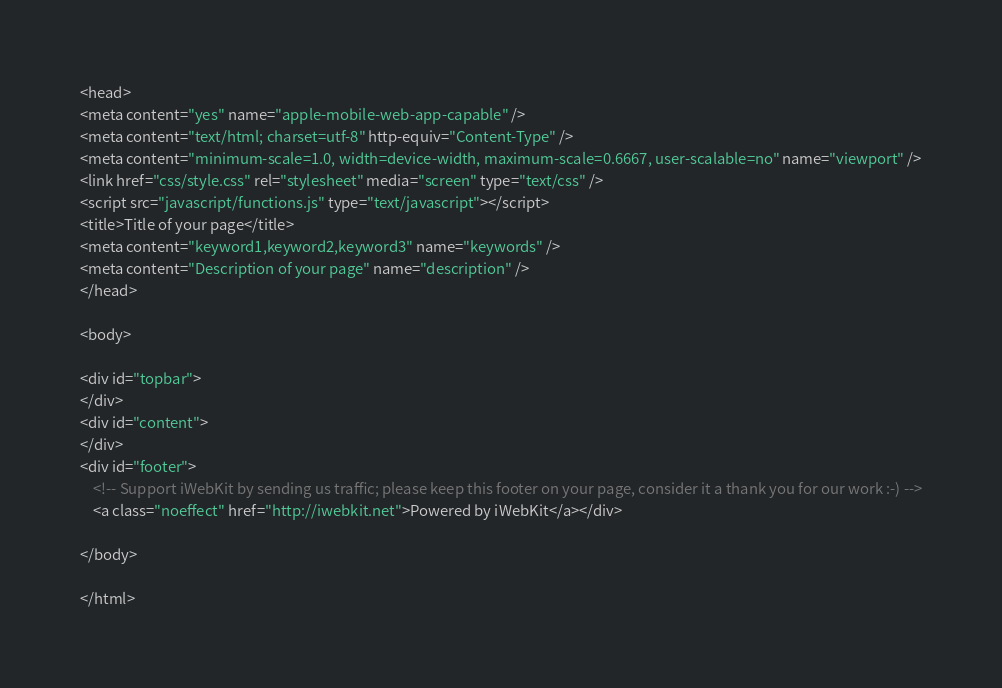Convert code to text. <code><loc_0><loc_0><loc_500><loc_500><_HTML_>
<head>
<meta content="yes" name="apple-mobile-web-app-capable" />
<meta content="text/html; charset=utf-8" http-equiv="Content-Type" />
<meta content="minimum-scale=1.0, width=device-width, maximum-scale=0.6667, user-scalable=no" name="viewport" />
<link href="css/style.css" rel="stylesheet" media="screen" type="text/css" />
<script src="javascript/functions.js" type="text/javascript"></script>
<title>Title of your page</title>
<meta content="keyword1,keyword2,keyword3" name="keywords" />
<meta content="Description of your page" name="description" />
</head>

<body>

<div id="topbar">
</div>
<div id="content">
</div>
<div id="footer">
	<!-- Support iWebKit by sending us traffic; please keep this footer on your page, consider it a thank you for our work :-) -->
	<a class="noeffect" href="http://iwebkit.net">Powered by iWebKit</a></div>

</body>

</html>
</code> 